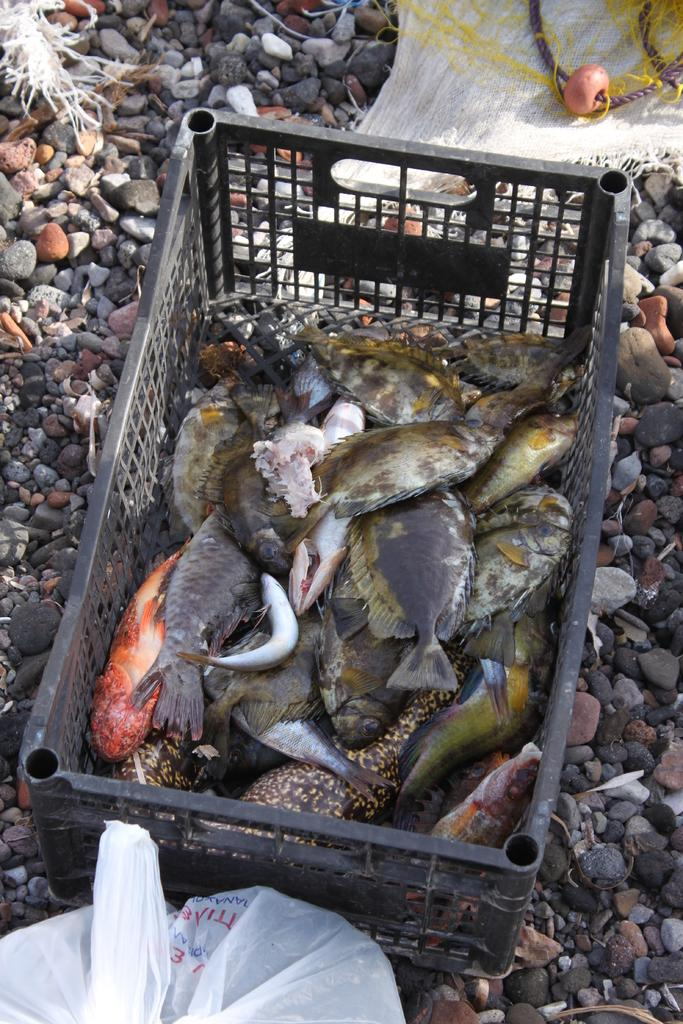What is inside the basket in the image? There are fishes in a basket in the image. What is located beside the basket? There is a plastic cover beside the basket. Can you describe any other objects or elements in the image? Yes, there are stones visible in the image. What type of button is being used to control the flame in the image? There is no button or flame present in the image. 